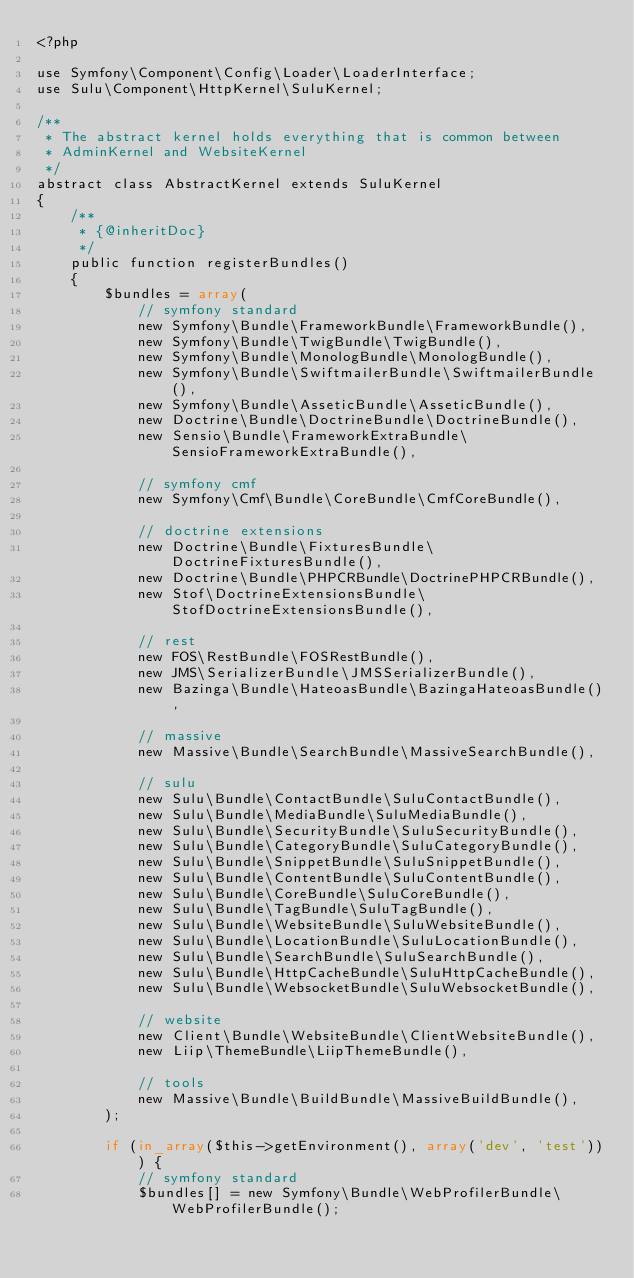<code> <loc_0><loc_0><loc_500><loc_500><_PHP_><?php

use Symfony\Component\Config\Loader\LoaderInterface;
use Sulu\Component\HttpKernel\SuluKernel;

/**
 * The abstract kernel holds everything that is common between
 * AdminKernel and WebsiteKernel
 */
abstract class AbstractKernel extends SuluKernel
{
    /**
     * {@inheritDoc}
     */
    public function registerBundles()
    {
        $bundles = array(
            // symfony standard
            new Symfony\Bundle\FrameworkBundle\FrameworkBundle(),
            new Symfony\Bundle\TwigBundle\TwigBundle(),
            new Symfony\Bundle\MonologBundle\MonologBundle(),
            new Symfony\Bundle\SwiftmailerBundle\SwiftmailerBundle(),
            new Symfony\Bundle\AsseticBundle\AsseticBundle(),
            new Doctrine\Bundle\DoctrineBundle\DoctrineBundle(),
            new Sensio\Bundle\FrameworkExtraBundle\SensioFrameworkExtraBundle(),

            // symfony cmf
            new Symfony\Cmf\Bundle\CoreBundle\CmfCoreBundle(),

            // doctrine extensions
            new Doctrine\Bundle\FixturesBundle\DoctrineFixturesBundle(),
            new Doctrine\Bundle\PHPCRBundle\DoctrinePHPCRBundle(),
            new Stof\DoctrineExtensionsBundle\StofDoctrineExtensionsBundle(),

            // rest
            new FOS\RestBundle\FOSRestBundle(),
            new JMS\SerializerBundle\JMSSerializerBundle(),
            new Bazinga\Bundle\HateoasBundle\BazingaHateoasBundle(),

            // massive
            new Massive\Bundle\SearchBundle\MassiveSearchBundle(),

            // sulu
            new Sulu\Bundle\ContactBundle\SuluContactBundle(),
            new Sulu\Bundle\MediaBundle\SuluMediaBundle(),
            new Sulu\Bundle\SecurityBundle\SuluSecurityBundle(),
            new Sulu\Bundle\CategoryBundle\SuluCategoryBundle(),
            new Sulu\Bundle\SnippetBundle\SuluSnippetBundle(),
            new Sulu\Bundle\ContentBundle\SuluContentBundle(),
            new Sulu\Bundle\CoreBundle\SuluCoreBundle(),
            new Sulu\Bundle\TagBundle\SuluTagBundle(),
            new Sulu\Bundle\WebsiteBundle\SuluWebsiteBundle(),
            new Sulu\Bundle\LocationBundle\SuluLocationBundle(),
            new Sulu\Bundle\SearchBundle\SuluSearchBundle(),
            new Sulu\Bundle\HttpCacheBundle\SuluHttpCacheBundle(),
            new Sulu\Bundle\WebsocketBundle\SuluWebsocketBundle(),

            // website
            new Client\Bundle\WebsiteBundle\ClientWebsiteBundle(),
            new Liip\ThemeBundle\LiipThemeBundle(),

            // tools
            new Massive\Bundle\BuildBundle\MassiveBuildBundle(),
        );

        if (in_array($this->getEnvironment(), array('dev', 'test'))) {
            // symfony standard
            $bundles[] = new Symfony\Bundle\WebProfilerBundle\WebProfilerBundle();</code> 